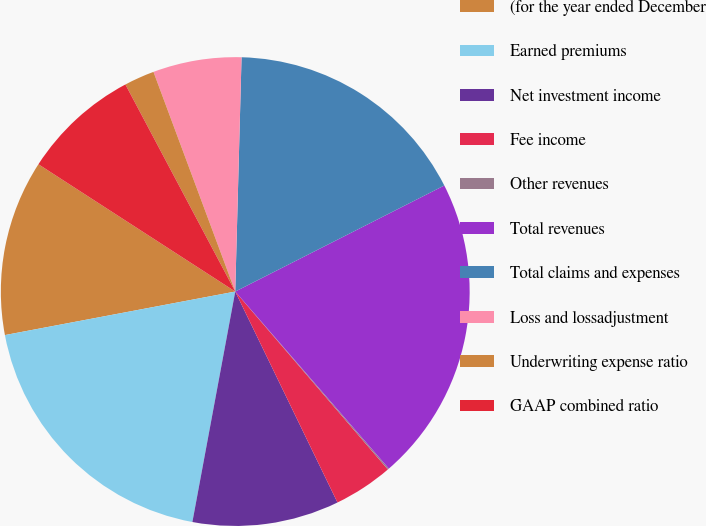<chart> <loc_0><loc_0><loc_500><loc_500><pie_chart><fcel>(for the year ended December<fcel>Earned premiums<fcel>Net investment income<fcel>Fee income<fcel>Other revenues<fcel>Total revenues<fcel>Total claims and expenses<fcel>Loss and lossadjustment<fcel>Underwriting expense ratio<fcel>GAAP combined ratio<nl><fcel>12.11%<fcel>19.1%<fcel>10.11%<fcel>4.1%<fcel>0.09%<fcel>21.1%<fcel>17.1%<fcel>6.1%<fcel>2.09%<fcel>8.1%<nl></chart> 